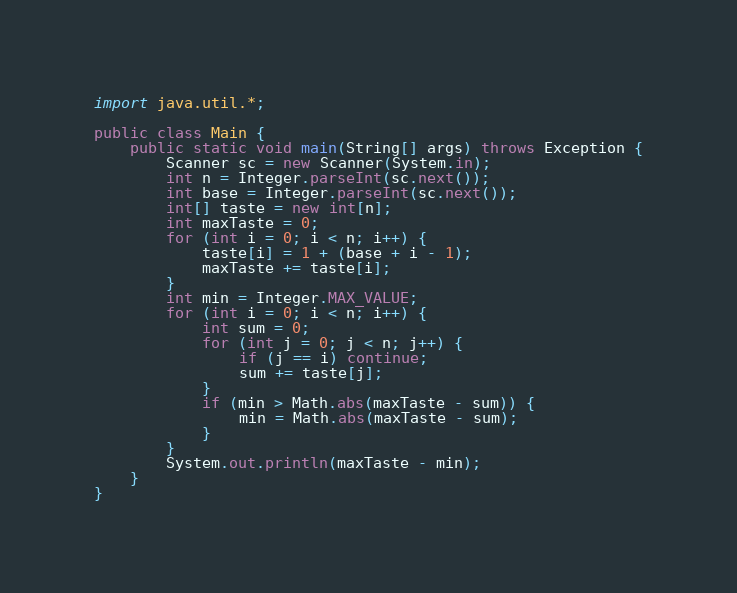Convert code to text. <code><loc_0><loc_0><loc_500><loc_500><_Java_>import java.util.*;

public class Main {
    public static void main(String[] args) throws Exception {
        Scanner sc = new Scanner(System.in);
        int n = Integer.parseInt(sc.next());
        int base = Integer.parseInt(sc.next());
        int[] taste = new int[n];
        int maxTaste = 0;
        for (int i = 0; i < n; i++) {
            taste[i] = 1 + (base + i - 1);
            maxTaste += taste[i];
        }
        int min = Integer.MAX_VALUE;
        for (int i = 0; i < n; i++) {
            int sum = 0;
            for (int j = 0; j < n; j++) {
                if (j == i) continue;
                sum += taste[j];
            }
            if (min > Math.abs(maxTaste - sum)) {
                min = Math.abs(maxTaste - sum);
            }
        }
        System.out.println(maxTaste - min);
    }
}</code> 